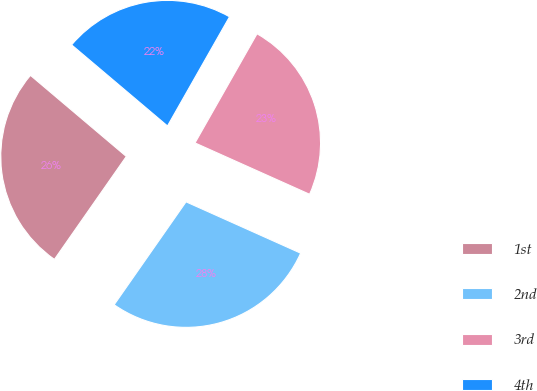Convert chart to OTSL. <chart><loc_0><loc_0><loc_500><loc_500><pie_chart><fcel>1st<fcel>2nd<fcel>3rd<fcel>4th<nl><fcel>26.47%<fcel>28.0%<fcel>23.48%<fcel>22.05%<nl></chart> 